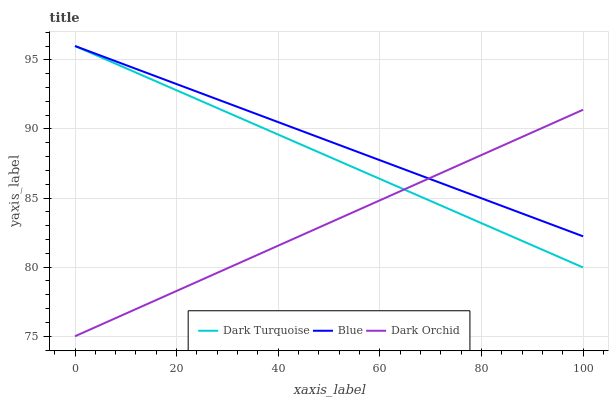Does Dark Orchid have the minimum area under the curve?
Answer yes or no. Yes. Does Blue have the maximum area under the curve?
Answer yes or no. Yes. Does Dark Turquoise have the minimum area under the curve?
Answer yes or no. No. Does Dark Turquoise have the maximum area under the curve?
Answer yes or no. No. Is Blue the smoothest?
Answer yes or no. Yes. Is Dark Orchid the roughest?
Answer yes or no. Yes. Is Dark Turquoise the smoothest?
Answer yes or no. No. Is Dark Turquoise the roughest?
Answer yes or no. No. Does Dark Turquoise have the lowest value?
Answer yes or no. No. Does Dark Turquoise have the highest value?
Answer yes or no. Yes. Does Dark Orchid have the highest value?
Answer yes or no. No. Does Dark Orchid intersect Blue?
Answer yes or no. Yes. Is Dark Orchid less than Blue?
Answer yes or no. No. Is Dark Orchid greater than Blue?
Answer yes or no. No. 